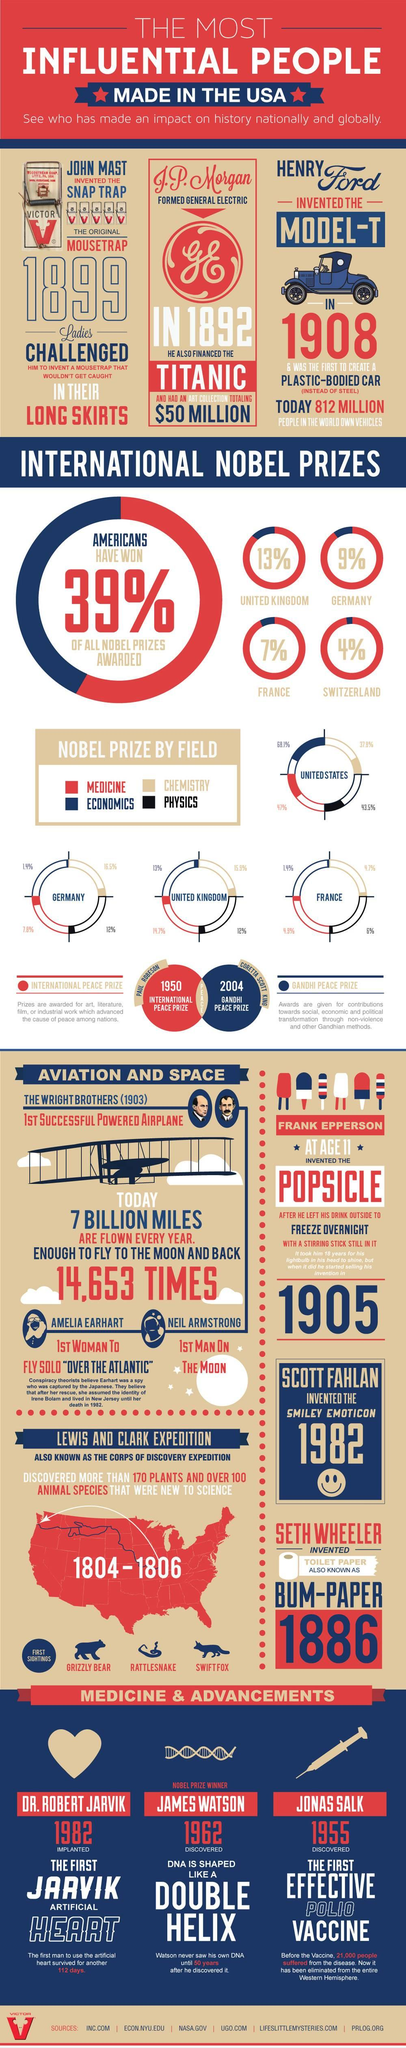Highlight a few significant elements in this photo. The Wright brothers are credited with inventing the first successful powered flight. It is widely known that the field of economics has produced the most Nobel Prize winners. Henry Ford invented the Model-T in 1908. In 1892, J.P. Morgan provided financial backing for the production of the iconic film, "Titanic. The percentage of Nobel Prizes won by France is 7%. 